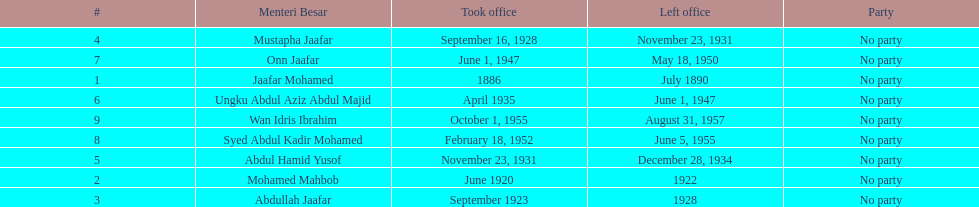Who is listed below onn jaafar? Syed Abdul Kadir Mohamed. 